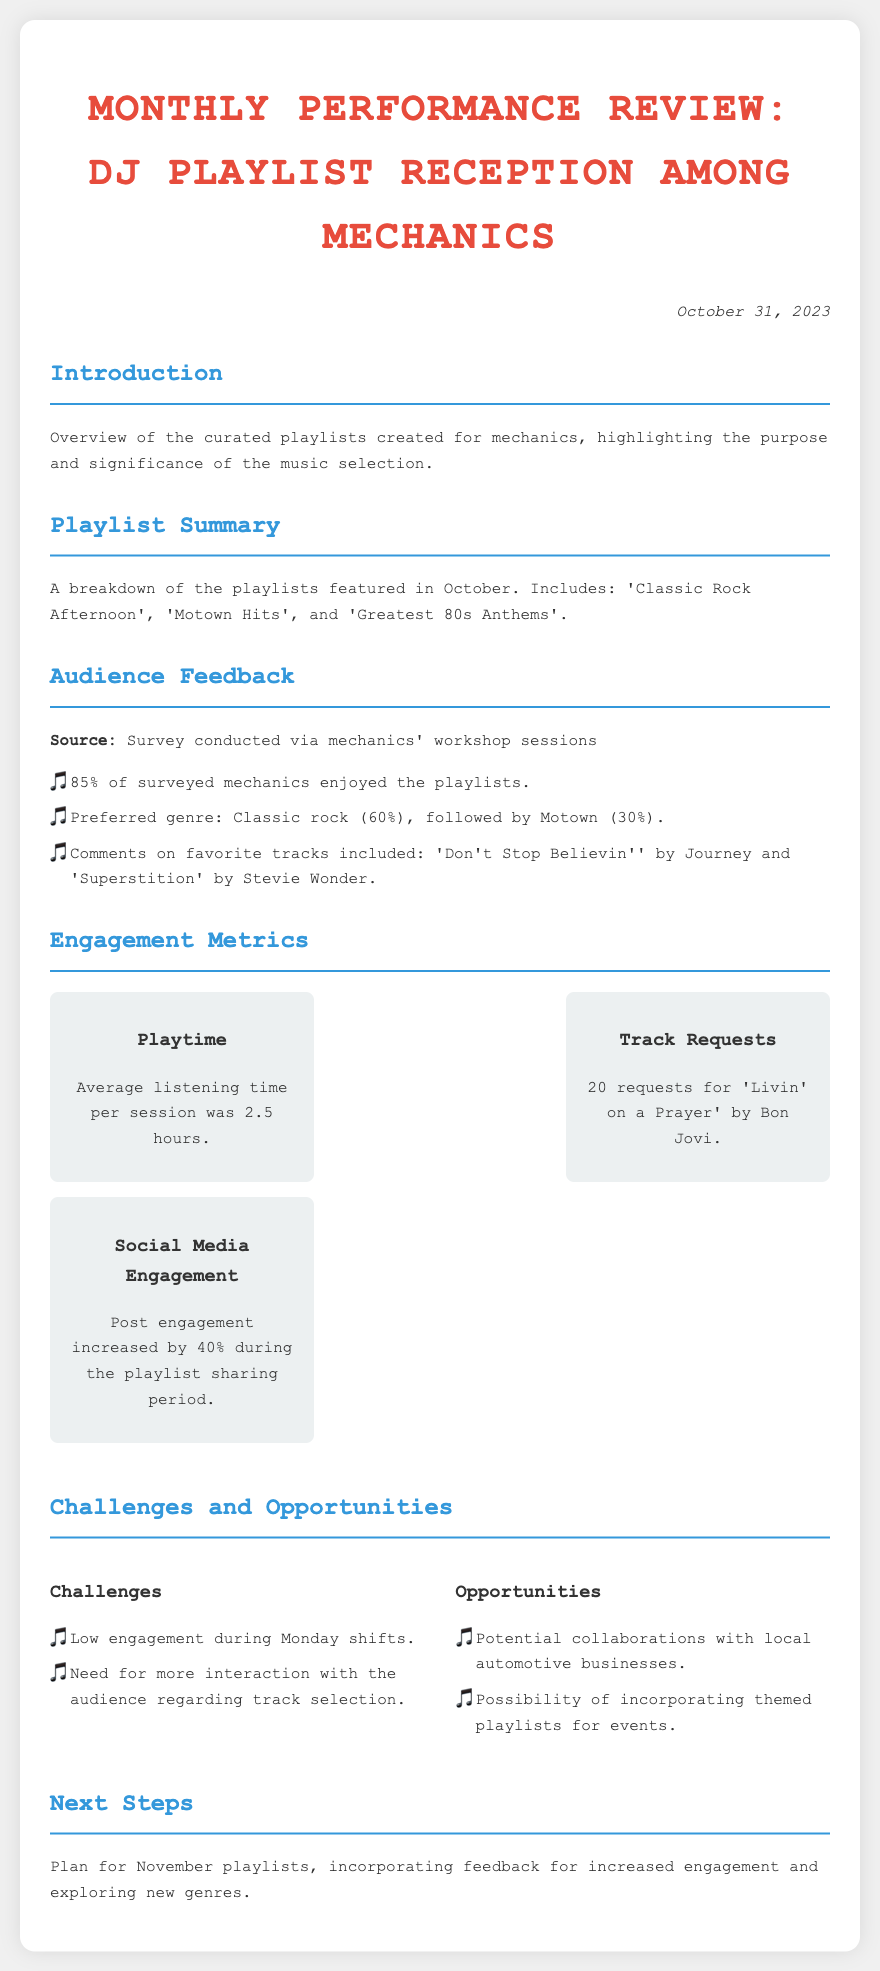What percentage of surveyed mechanics enjoyed the playlists? The document states that 85% of surveyed mechanics enjoyed the playlists.
Answer: 85% What genre was preferred by the majority of mechanics? According to the document, the preferred genre among surveyed mechanics was classic rock, which accounted for 60%.
Answer: Classic rock How long was the average listening time per session? The document mentions that the average listening time per session was 2.5 hours.
Answer: 2.5 hours How many requests were made for 'Livin' on a Prayer'? The document indicates there were 20 requests for 'Livin' on a Prayer' by Bon Jovi.
Answer: 20 What increase percentage was noted in social media engagement? The document reports a 40% increase in social media engagement during the playlist sharing period.
Answer: 40% What was a noted challenge during the mechanics' shifts? The document mentions low engagement during Monday shifts as a challenge encountered by the DJ.
Answer: Low engagement during Monday shifts What is one opportunity mentioned for increasing engagement? The document highlights the potential for collaborations with local automotive businesses as an opportunity.
Answer: Collaborations with local automotive businesses What was the date of the performance review? The document clearly states that the performance review was conducted on October 31, 2023.
Answer: October 31, 2023 What was one of the favorite tracks mentioned by mechanics? The document lists 'Don't Stop Believin'' by Journey as one of the favorite tracks.
Answer: Don't Stop Believin' 